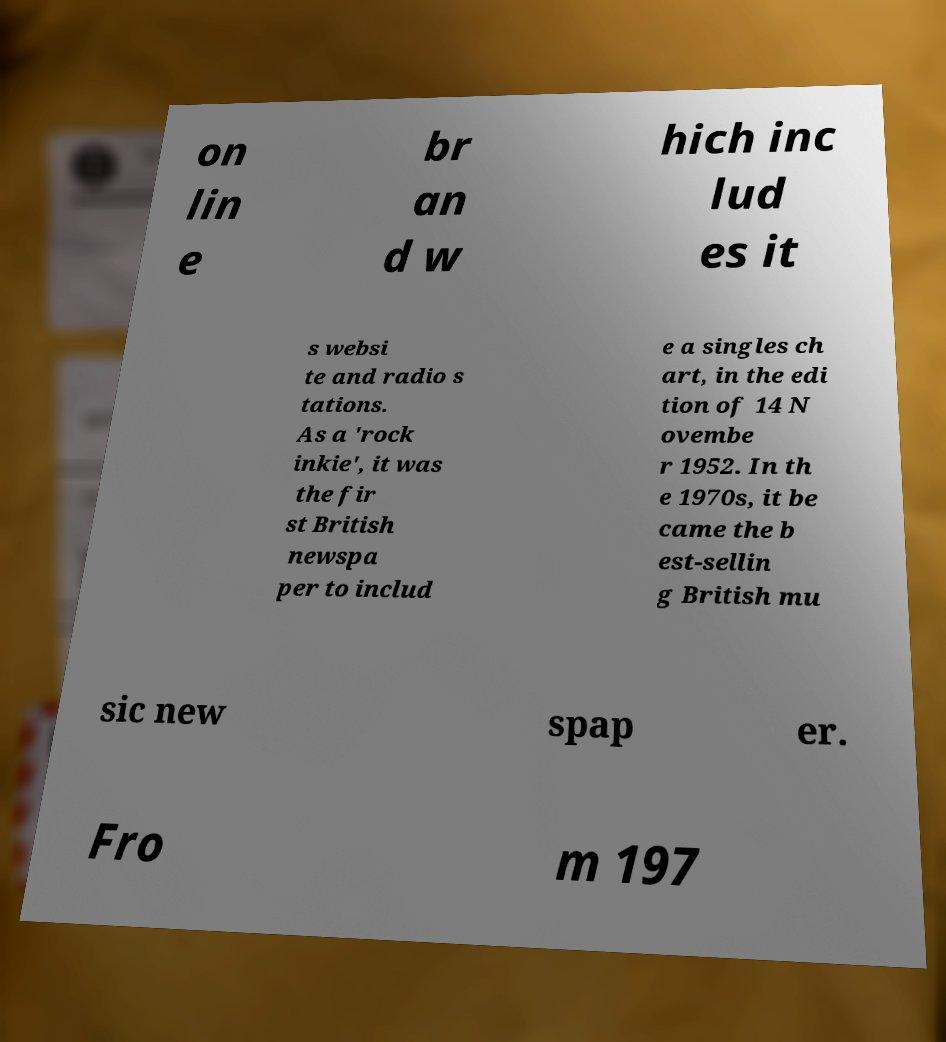Can you read and provide the text displayed in the image?This photo seems to have some interesting text. Can you extract and type it out for me? on lin e br an d w hich inc lud es it s websi te and radio s tations. As a 'rock inkie', it was the fir st British newspa per to includ e a singles ch art, in the edi tion of 14 N ovembe r 1952. In th e 1970s, it be came the b est-sellin g British mu sic new spap er. Fro m 197 